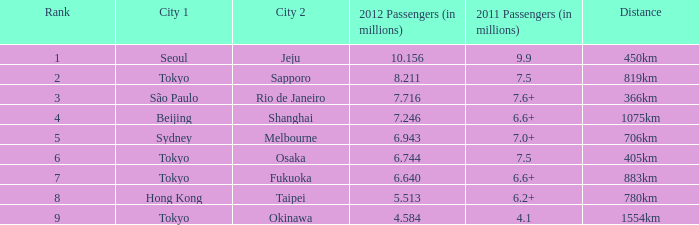6 million travelers? São Paulo. 